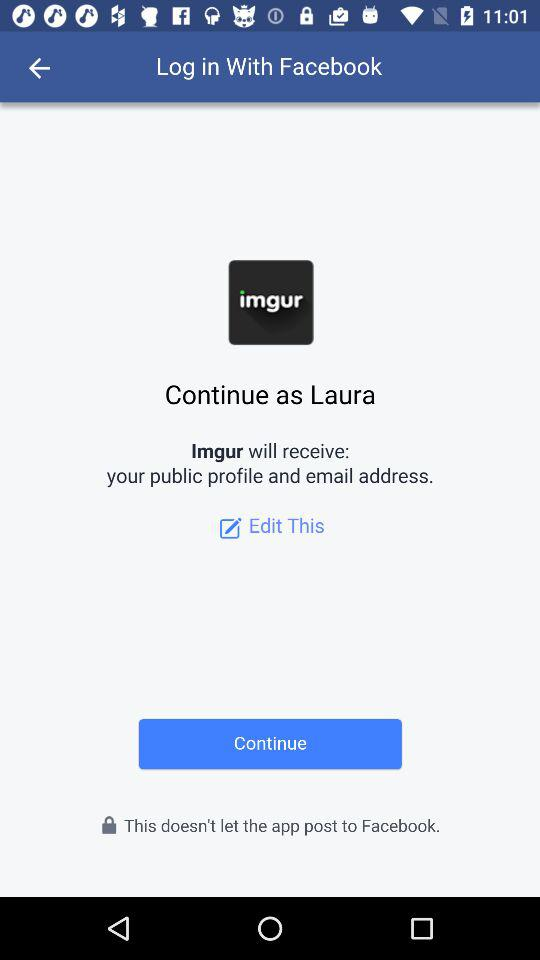Through which application is the person logging in? The application is "Facebook". 